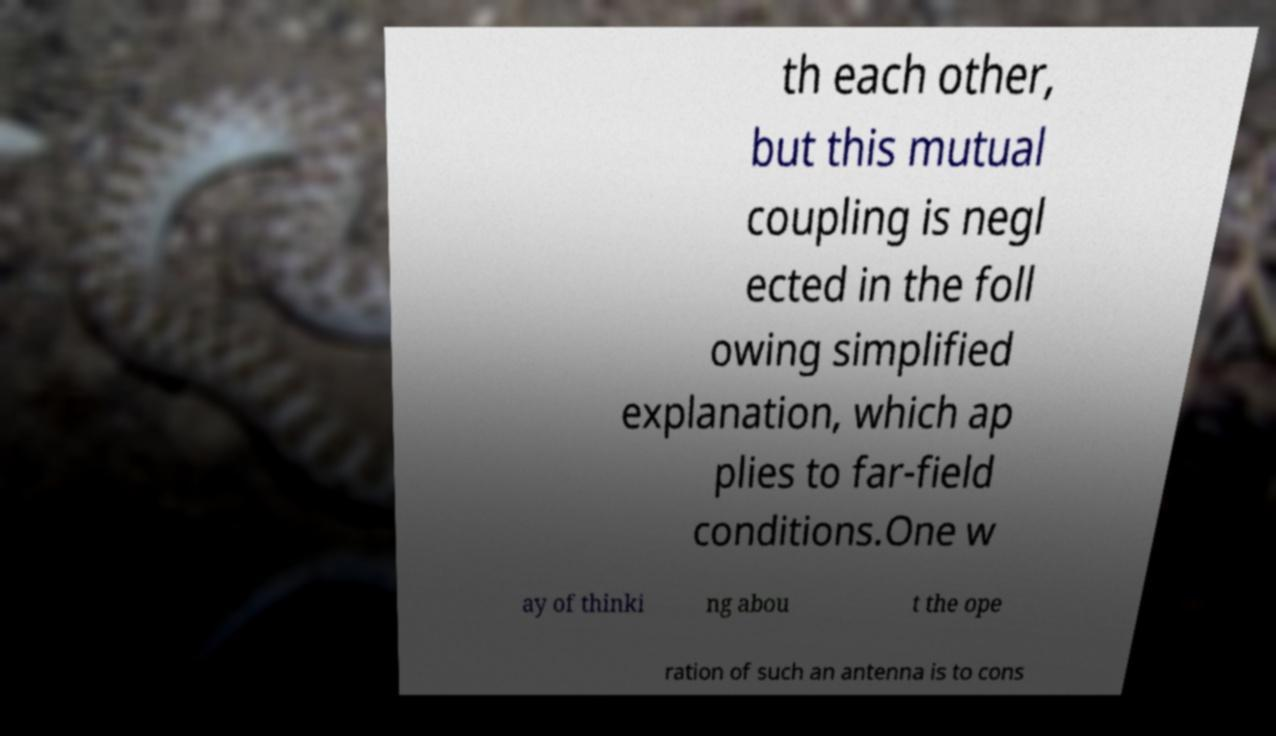What messages or text are displayed in this image? I need them in a readable, typed format. th each other, but this mutual coupling is negl ected in the foll owing simplified explanation, which ap plies to far-field conditions.One w ay of thinki ng abou t the ope ration of such an antenna is to cons 